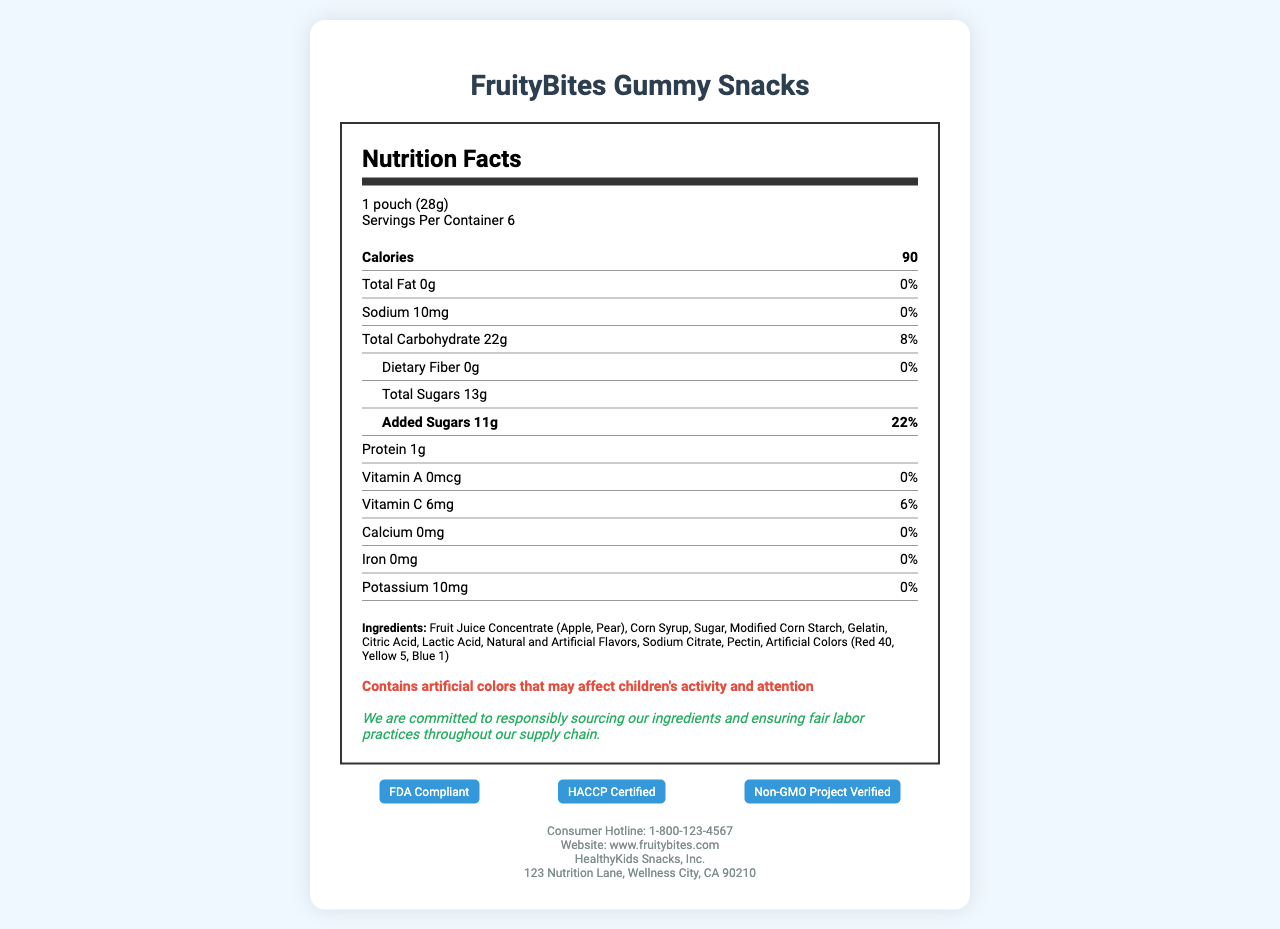What is the calorie count per serving? The nutrition label explicitly states that each serving contains 90 calories.
Answer: 90 calories What is the amount of added sugars in one serving? The label indicates that there are 11 grams of added sugars per serving.
Answer: 11g Does the product contain any dietary fiber? The nutrition label shows that the dietary fiber content is 0 grams.
Answer: No, it contains 0g of dietary fiber What are the total carbohydrates in one serving? The label specifies that the total carbohydrate content per serving is 22 grams.
Answer: 22g What vitamins are present in FruityBites Gummy Snacks? The label lists Vitamin C with an amount of 6mg (6% daily value), but Vitamin A is at 0%.
Answer: Vitamin C Does the product have any major allergens? The allergen information section states that the product contains no major allergens.
Answer: No What warning is included regarding artificial colors? The warning explicitly notes the possible effects of artificial colors on children's activity and attention.
Answer: Contains artificial colors that may affect children's activity and attention What compliance certifications does the product have? This information is listed under compliance certifications.
Answer: FDA Compliant, HACCP Certified, Non-GMO Project Verified What ethical statement does the company make about sourcing? The ethical sourcing statement provided declares this commitment.
Answer: Committed to responsibly sourcing ingredients and ensuring fair labor practices How many servings are there per container? The serving information indicates that there are 6 servings per container.
Answer: 6 What is the serving size? The serving size is stated as 1 pouch (28 grams).
Answer: 1 pouch (28g) Is the product fat-free? The label shows the total fat content as 0 grams, and the nutritional claims confirm that the product is fat-free.
Answer: Yes What is the amount of protein in one serving? The nutrition label indicates that each serving contains 1 gram of protein.
Answer: 1g When looking at the total carbohydrate content, which sub-component has the highest value? The total carbohydrate breakdown includes dietary fiber (0g), but the total sugars (13g) are the highest sub-component.
Answer: Total Sugars (13g) What should you do if you need more information about the product? A. Check the website B. Call the consumer hotline C. Write a letter D. Visit the store The contact information section provides a consumer hotline number for inquiries.
Answer: B. Call the consumer hotline Which of the following is not a listed ingredient? I. Apple Juice Concentrate II. Corn Syrup III. Vitamin D IV. Gelatin The list of ingredients does not include Vitamin D.
Answer: III. Vitamin D Does the product contain any artificial preservatives? The nutritional claims mention that there are no artificial preservatives in the product.
Answer: No Summarize the key nutritional and compliance information of FruityBites Gummy Snacks. The document primarily highlights the nutritional content per serving, including calories, macronutrients, and vitamins. It provides details on ingredients, allergen information, and warnings about artificial colors. Additionally, it verifies the product's compliance certifications and ethical sourcing statements, along with contact information for consumers.
Answer: FruityBites Gummy Snacks are a children's snack containing 90 calories per serving, with 0g total fat, 22g total carbohydrate (including 13g total sugars and 11g added sugars), 1g protein, and vitamins C but no major allergens. The product contains artificial colors, and the company commits to ethical sourcing. It holds multiple compliance certifications: FDA Compliant, HACCP Certified, and Non-GMO Project Verified. What is the source of the fruit juice concentrate? The label states "Fruit Juice Concentrate (Apple, Pear)" but does not specify the exact source of the concentration process or origin of the fruits.
Answer: Not enough information 